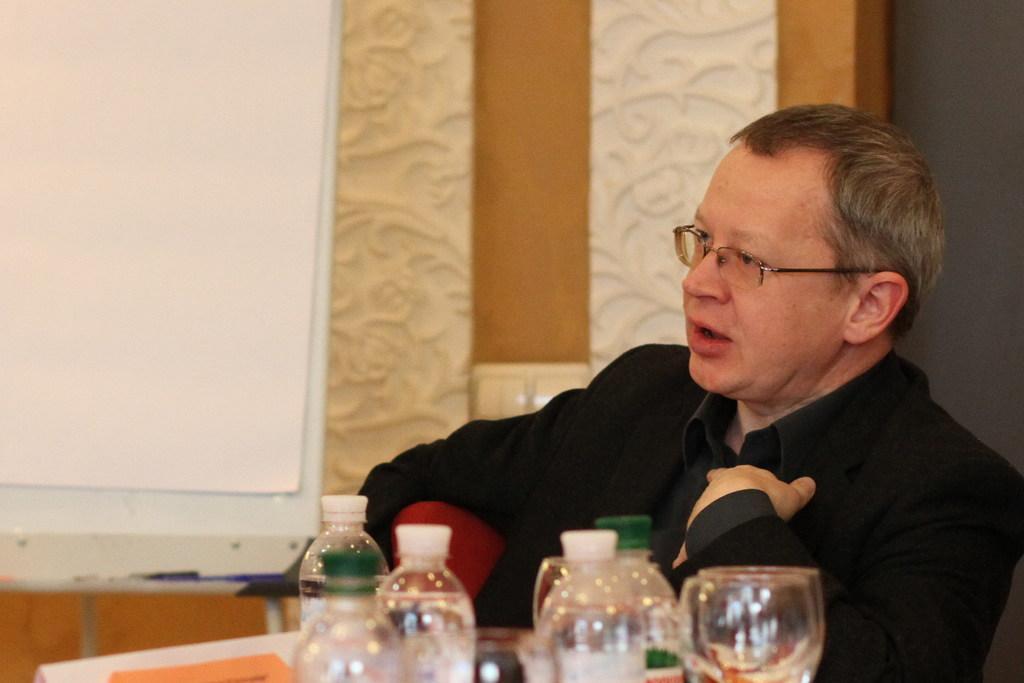Can you describe this image briefly? The person wearing black suit is sitting in a chair and there are water bottles and glasses in front of him. 